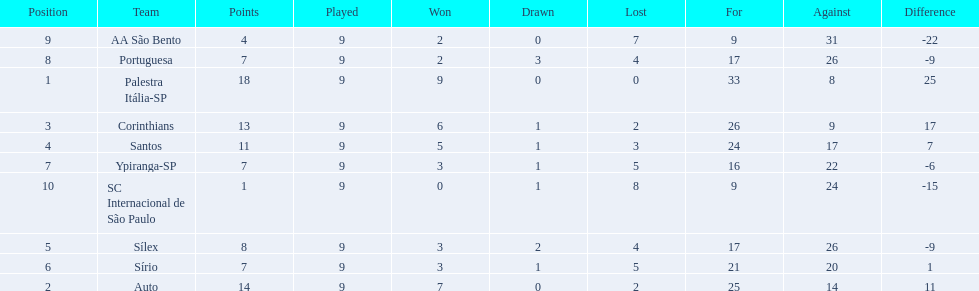How many games did each team play? 9, 9, 9, 9, 9, 9, 9, 9, 9, 9. Did any team score 13 points in the total games they played? 13. What is the name of that team? Corinthians. 